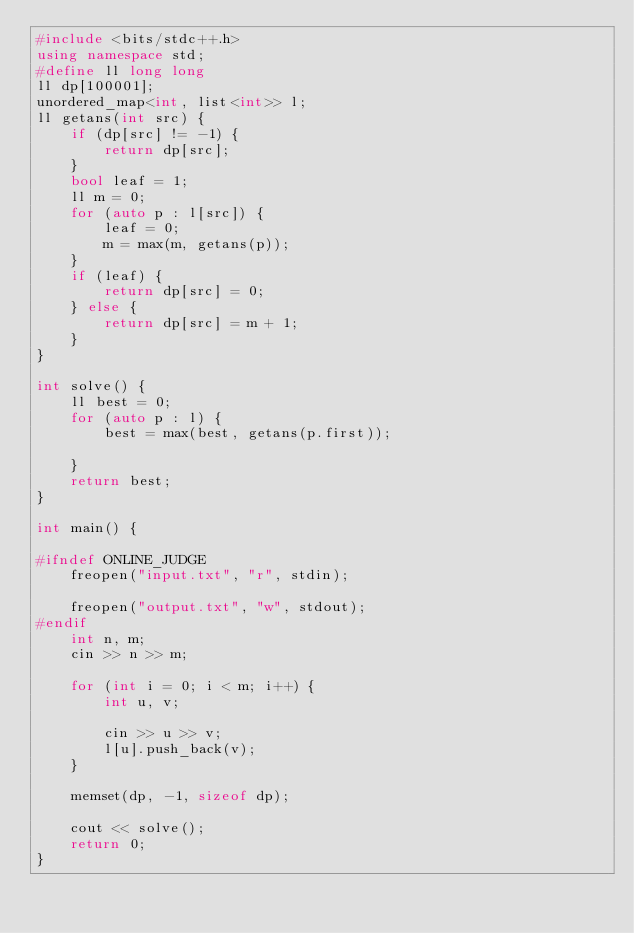Convert code to text. <code><loc_0><loc_0><loc_500><loc_500><_C++_>#include <bits/stdc++.h>
using namespace std;
#define ll long long
ll dp[100001];
unordered_map<int, list<int>> l;
ll getans(int src) {
	if (dp[src] != -1) {
		return dp[src];
	}
	bool leaf = 1;
	ll m = 0;
	for (auto p : l[src]) {
		leaf = 0;
		m = max(m, getans(p));
	}
	if (leaf) {
		return dp[src] = 0;
	} else {
		return dp[src] = m + 1;
	}
}

int solve() {
	ll best = 0;
	for (auto p : l) {
		best = max(best, getans(p.first));

	}
	return best;
}

int main() {

#ifndef ONLINE_JUDGE
	freopen("input.txt", "r", stdin);

	freopen("output.txt", "w", stdout);
#endif
	int n, m;
	cin >> n >> m;

	for (int i = 0; i < m; i++) {
		int u, v;

		cin >> u >> v;
		l[u].push_back(v);
	}

	memset(dp, -1, sizeof dp);

	cout << solve();
	return 0;
}</code> 